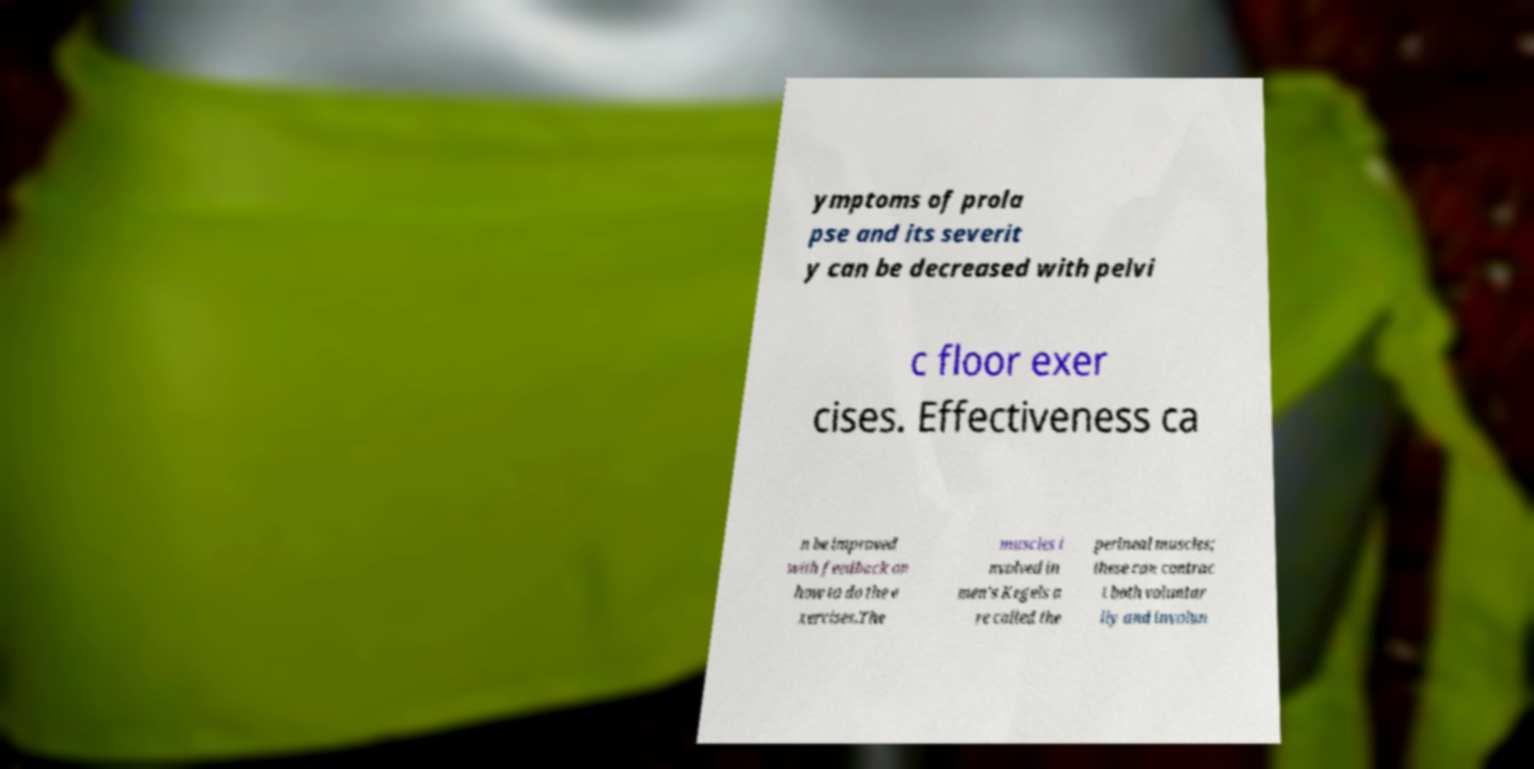Can you read and provide the text displayed in the image?This photo seems to have some interesting text. Can you extract and type it out for me? ymptoms of prola pse and its severit y can be decreased with pelvi c floor exer cises. Effectiveness ca n be improved with feedback on how to do the e xercises.The muscles i nvolved in men's Kegels a re called the perineal muscles; these can contrac t both voluntar ily and involun 